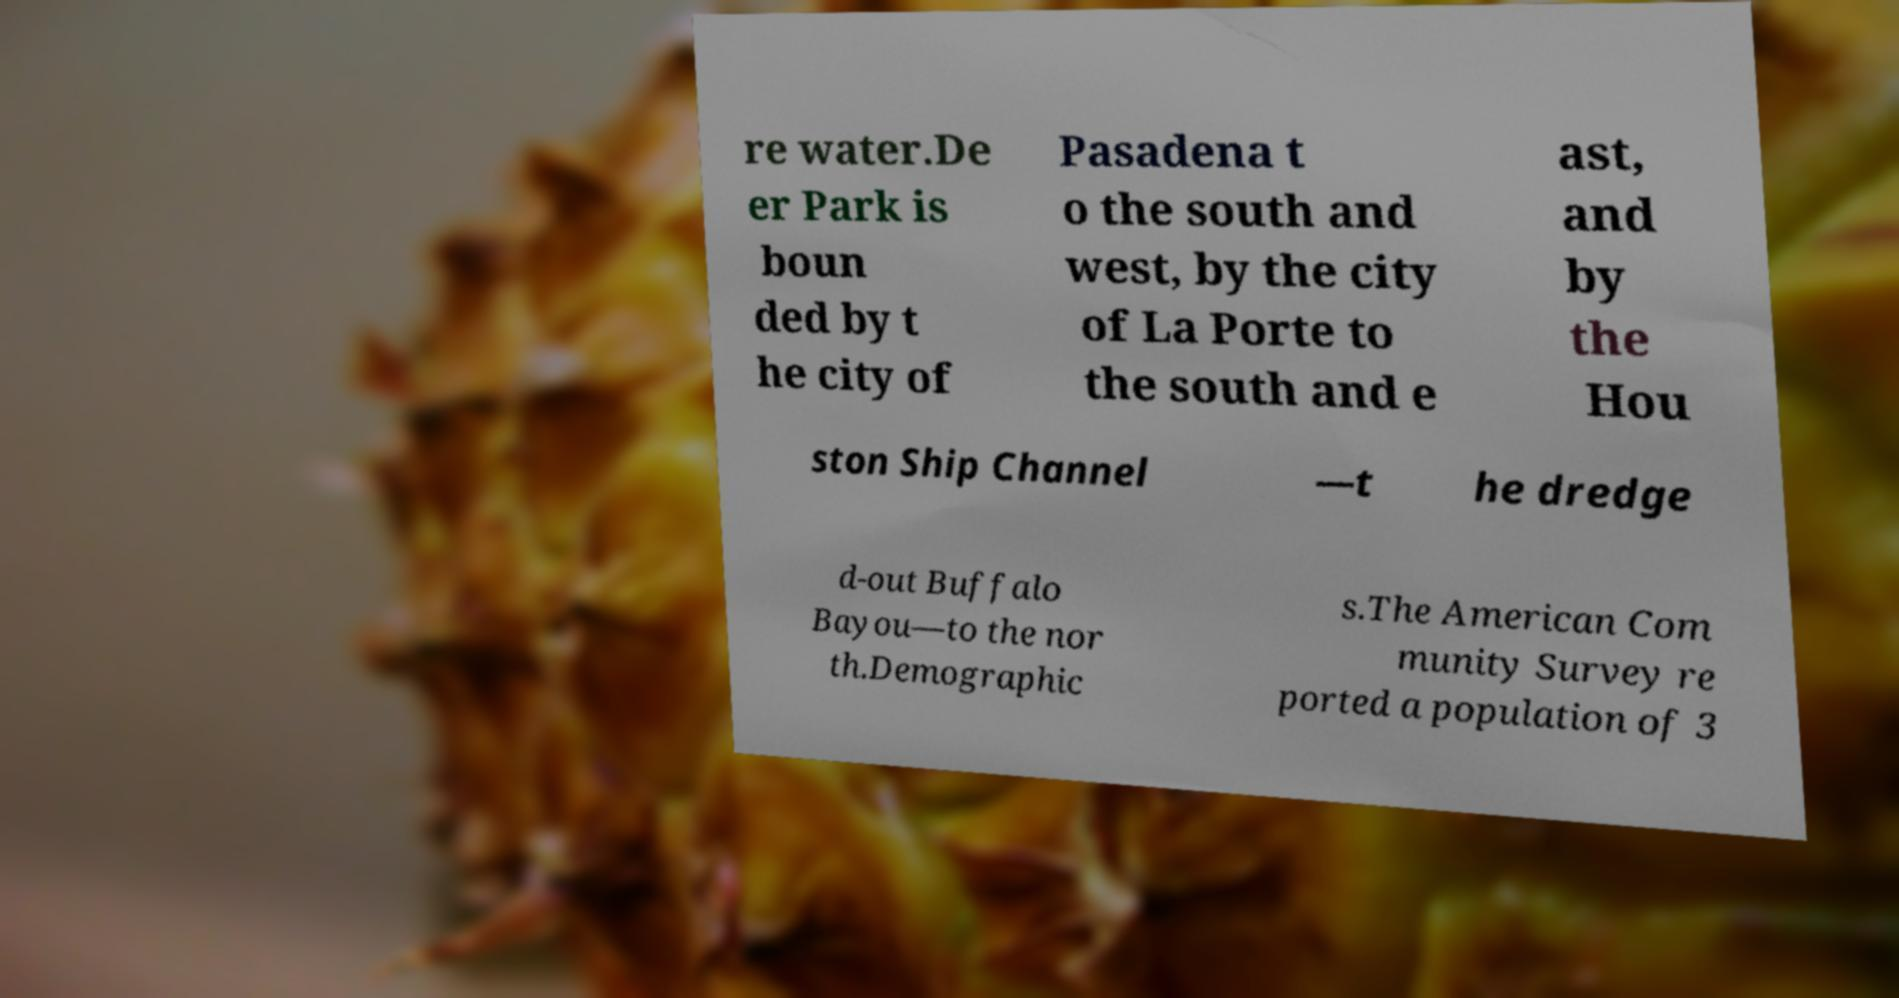Can you read and provide the text displayed in the image?This photo seems to have some interesting text. Can you extract and type it out for me? re water.De er Park is boun ded by t he city of Pasadena t o the south and west, by the city of La Porte to the south and e ast, and by the Hou ston Ship Channel —t he dredge d-out Buffalo Bayou—to the nor th.Demographic s.The American Com munity Survey re ported a population of 3 